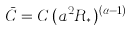<formula> <loc_0><loc_0><loc_500><loc_500>\bar { C } = C \, ( a ^ { 2 } R _ { \ast } ) ^ { ( \alpha - 1 ) }</formula> 